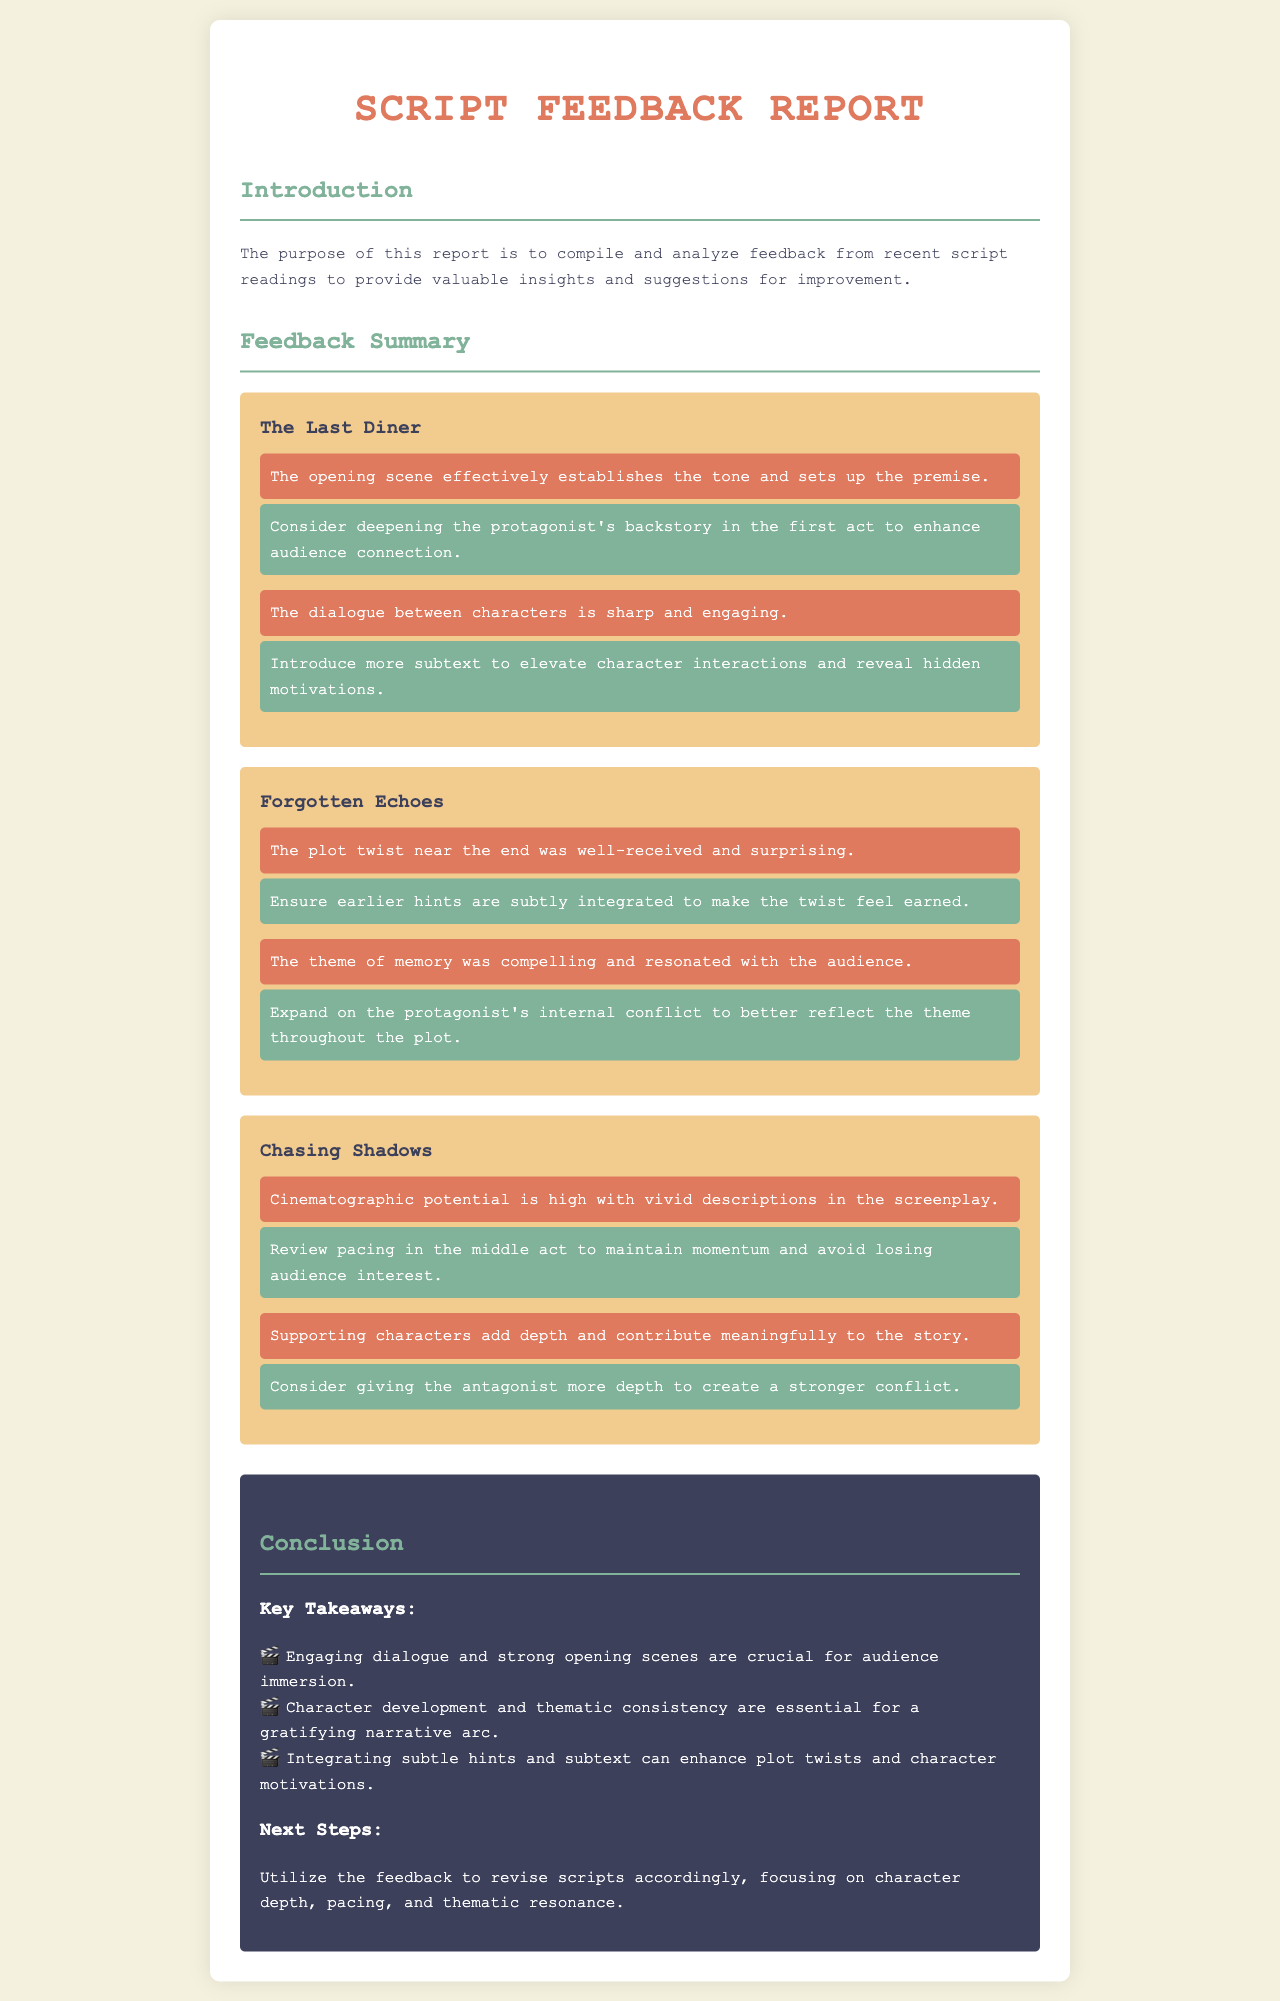What is the title of the first script discussed? The title is explicitly stated under the "script-feedback" section for "The Last Diner".
Answer: The Last Diner How many insights are provided for "Forgotten Echoes"? The feedback item breakdown includes insight feedback for "Forgotten Echoes", which has two insights.
Answer: 2 What is one suggestion made for "Chasing Shadows"? Detailed feedback includes suggestions for improving "Chasing Shadows", specifically mentioning reviewing pacing as a suggestion.
Answer: Review pacing What theme resonated in "Forgotten Echoes"? The document cites the compelling theme that resonated with the audience, specifically mentioning memory in relation to the script.
Answer: Memory Which script was noted for having high cinematographic potential? The feedback provides insights on scripts, highlighting "Chasing Shadows" as having vivid descriptions with high cinematographic potential.
Answer: Chasing Shadows What is one key takeaway from the conclusion? The document summarizes points in the conclusion, mentioning the importance of engaging dialogue for audience immersion as a key takeaway.
Answer: Engaging dialogue What is the feedback color for suggestions in the document? The unique design highlights suggestions using a specific background color that sets them apart from insights.
Answer: Green What is suggested to enhance character interactions? A specific suggestion is made regarding enhancing character interactions through the introduction of more subtext in the dialogue.
Answer: More subtext How many scripts are analyzed in the feedback summary? The detailed feedback section includes analysis for three distinct scripts.
Answer: 3 